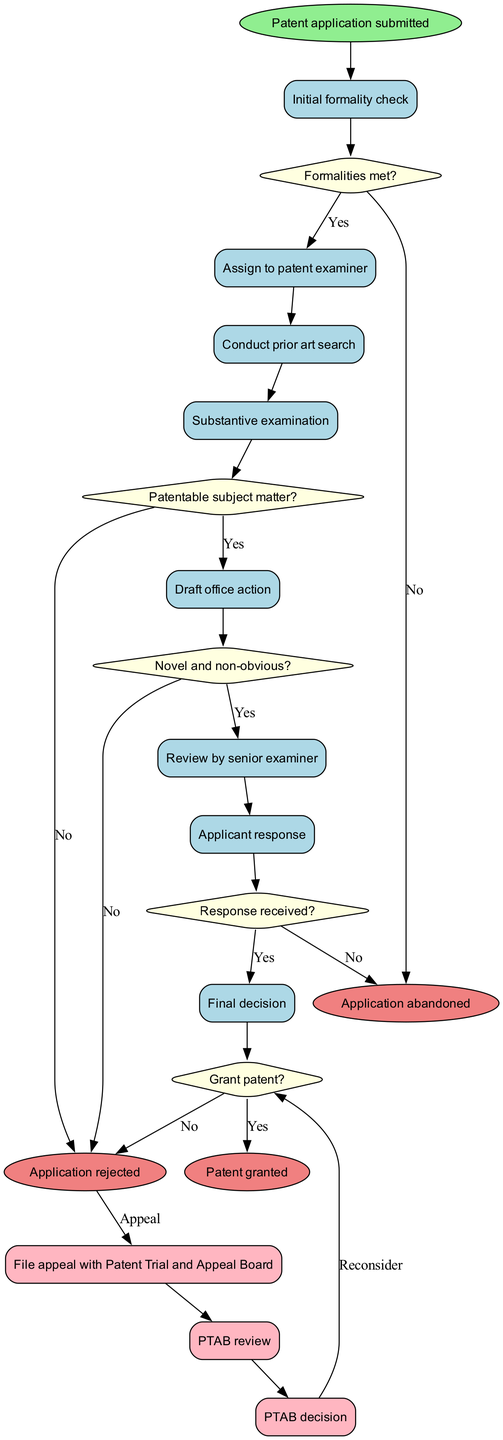What is the start node of the diagram? The start node is explicitly defined in the diagram as the point where the process begins, which is indicated as "Patent application submitted."
Answer: Patent application submitted How many end nodes are there in the diagram? The end nodes are labeled and can be counted directly from the diagram; there are three distinct end nodes shown.
Answer: 3 What is the first decision point in the process? The first decision point, located after the initial formality check, is clearly labeled as "Formalities met?" and leads to subsequent actions based on the response.
Answer: Formalities met? What happens if the applicant's response is received positively? If a positive response is received (indicated by "Yes"), the flow continues to "Final decision," which ultimately leads to either grant or rejection of the patent, showing the next steps of the process.
Answer: Final decision Which activity follows the substantive examination? Directly following the "Substantive examination" activity in the flow, the next activity outlined is "Draft office action." This indicates the progression of the review process following substantive examination.
Answer: Draft office action What are the three possible outcomes at the end of the process? The diagram lists three distinct end nodes that reflect the final decisions regarding the patent application, capturing the possible outcomes which are detailed as individual nodes.
Answer: Patent granted, Application rejected, Application abandoned What is the connection from the "Application rejected" node? The diagram connects the "Application rejected" node to the appeal process with an edge marked "Appeal," indicating the possibility for the applicant to challenge the rejection decision.
Answer: Appeal What initiates the appeal process after an application rejection? The initiation of the appeal process is triggered by an action derived from the node "Application rejected," as clarified through the transition leading to the appeal steps.
Answer: File appeal with Patent Trial and Appeal Board What happens after the PTAB review? Following the "PTAB review" in the appeal process, the diagram shows that it leads to the "PTAB decision" node, where a final judgment on the appeal is rendered, indicating the completion of that review pathway.
Answer: PTAB decision 